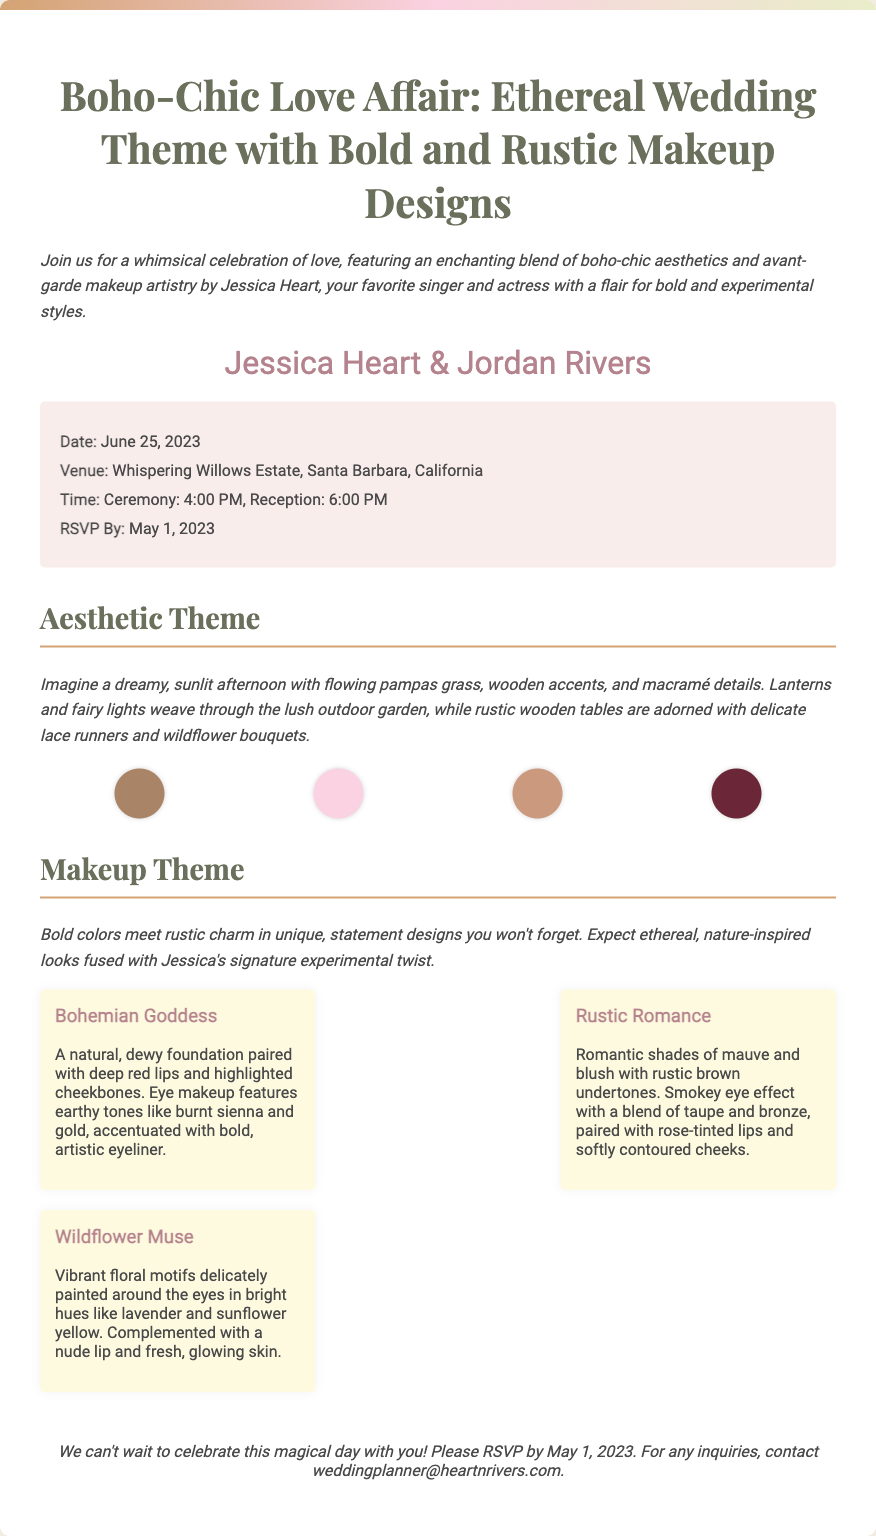What is the theme of the wedding? The theme of the wedding is described prominently in the title and theme description, which highlights a blend of boho-chic aesthetics and makeup artistry.
Answer: Boho-Chic Love Affair What is the date of the wedding? The date is specifically mentioned in the details section of the invitation.
Answer: June 25, 2023 Where is the wedding venue located? The venue is listed in the details, indicating where the ceremony will take place.
Answer: Whispering Willows Estate, Santa Barbara, California What time does the ceremony start? The time of the ceremony is stated clearly in the details section.
Answer: 4:00 PM What is the RSVP deadline? The RSVP deadline is provided in the details section of the document.
Answer: May 1, 2023 What makeup look features earthy tones? This question requires understanding the descriptions of the makeup concepts provided in the document.
Answer: Bohemian Goddess Which makeup look includes vibrant floral motifs? The description specifies which makeup look contains floral designs as part of its theme.
Answer: Wildflower Muse What color is included in the rustic makeup palette? The colors are specifically listed in the color palette section, and some of them indicate rustic tones.
Answer: Brown How many makeup looks are described? The number of makeup looks can be counted from the section detailing the different styles presented.
Answer: Three 